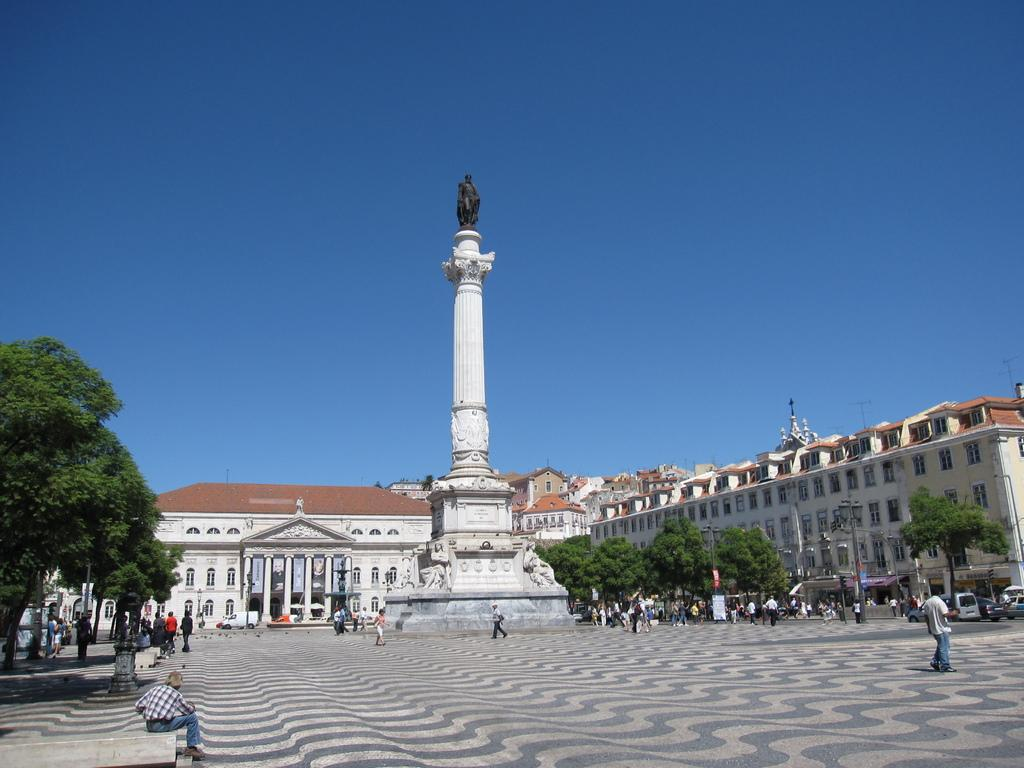How many people are in the group visible in the image? There is a group of people in the image, but the exact number cannot be determined from the provided facts. What types of vehicles are on the ground in the image? The provided facts do not specify the types of vehicles present in the image. What is the statue on top of in the image? The statue is on a tower in the image. What type of vegetation is present in the image? There are trees in the image. What architectural features can be seen on the buildings in the image? The buildings in the image have windows. What other objects can be seen in the image? The provided facts mention that there are some objects in the image, but their specific nature is not described. What can be seen in the background of the image? The sky is visible in the background of the image. What type of cherry is being used as a decoration on the minister's hat in the image? There is no minister or cherry present in the image. What phase is the moon in the image? The provided facts do not mention the moon or its phase in the image. 